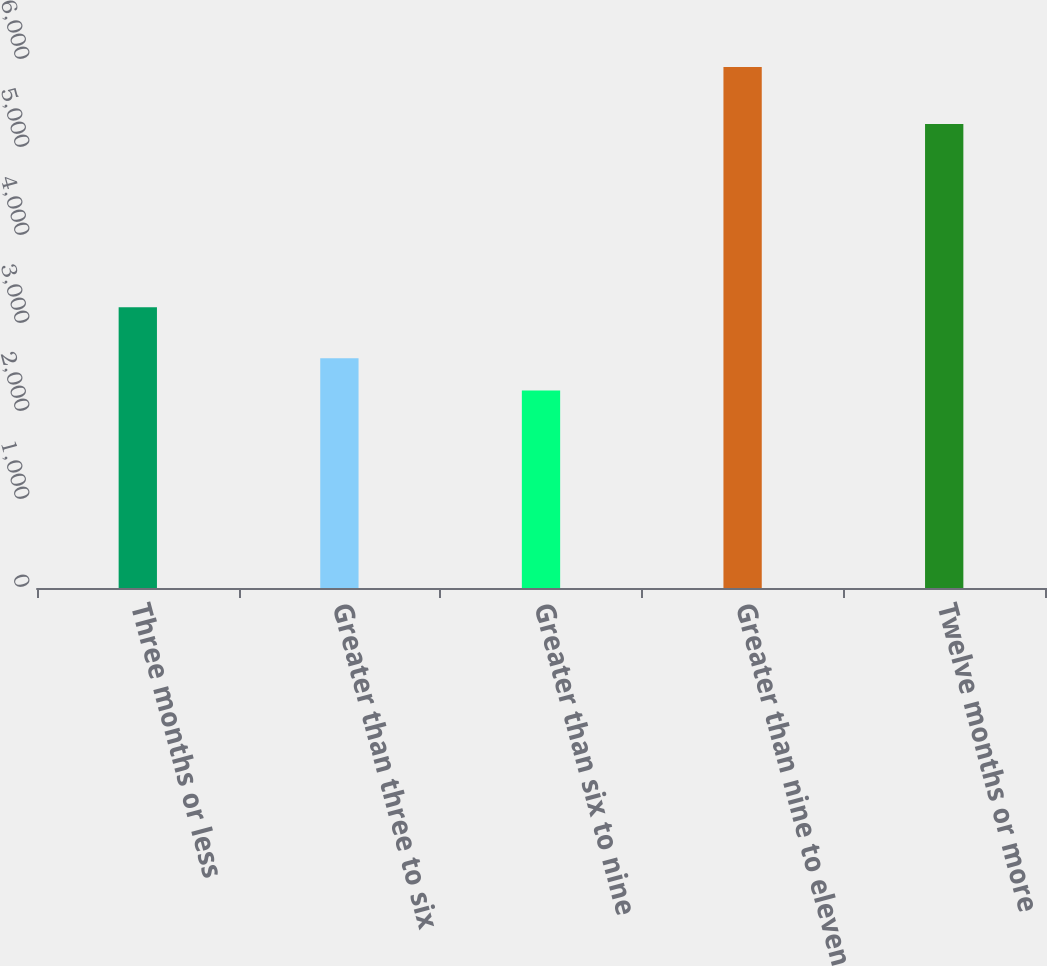Convert chart. <chart><loc_0><loc_0><loc_500><loc_500><bar_chart><fcel>Three months or less<fcel>Greater than three to six<fcel>Greater than six to nine<fcel>Greater than nine to eleven<fcel>Twelve months or more<nl><fcel>3191<fcel>2610.8<fcel>2243<fcel>5921<fcel>5272<nl></chart> 